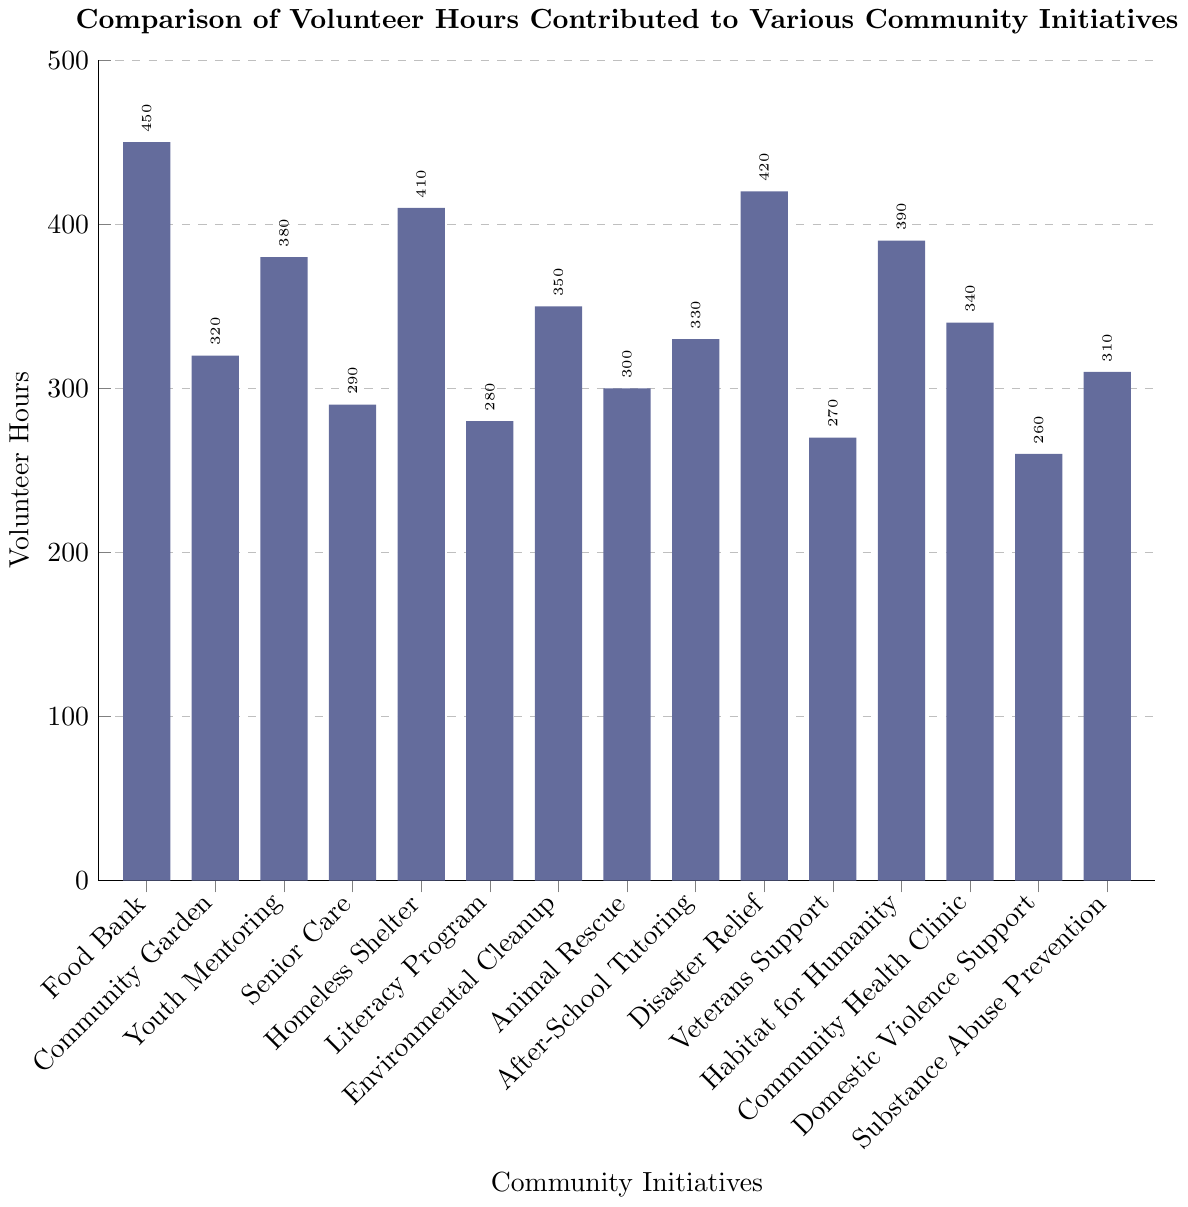What initiative received the highest number of volunteer hours? The initiative with the highest bar corresponds to the Food Bank with 450 volunteer hours.
Answer: Food Bank Which two initiatives have the closest number of volunteer hours? By visually comparing the heights of the bars, Habitate for Humanity (390 hours) and Youth Mentoring (380 hours) have the closest values.
Answer: Habitat for Humanity and Youth Mentoring What is the difference in volunteer hours between the initiative with the highest and the lowest contributions? The highest volunteer hours are for Food Bank (450 hours), and the lowest is for Domestic Violence Support (260 hours). The difference is 450 - 260 = 190 hours.
Answer: 190 hours How many initiatives have volunteer hours greater than 350 hours? Initiatives with more than 350 hours are Food Bank (450), Homeless Shelter (410), Disaster Relief (420), Habitat for Humanity (390), and Youth Mentoring (380), totaling 5 initiatives.
Answer: 5 initiatives What is the total number of volunteer hours for all initiatives combined? Summing all the volunteer hours given:
450 + 320 + 380 + 290 + 410 + 280 + 350 + 300 + 330 + 420 + 270 + 390 + 340 + 260 + 310 = 5500 hours.
Answer: 5500 hours What is the average number of volunteer hours across all initiatives? First, find the total hours, which is 5500 hours. There are 15 initiatives. So, the average is 5500 / 15 = approximately 366.67 hours.
Answer: 366.67 hours Which initiatives have volunteer hours below the average? The average is approximately 366.67 hours. Initiatives below this value include:
- Community Garden (320 hours)
- Senior Care (290 hours)
- Literacy Program (280 hours)
- Animal Rescue (300 hours)
- Veterans Support (270 hours)
- Domestic Violence Support (260 hours)
- Substance Abuse Prevention (310 hours)
Answer: Community Garden, Senior Care, Literacy Program, Animal Rescue, Veterans Support, Domestic Violence Support, Substance Abuse Prevention What is the combined volunteer hours for Environment Cleanup, Animal Rescue, and Community Health Clinic? Their hours are 350 + 300 + 340. Adding these gives 350 + 300 = 650, then 650 + 340 = 990.
Answer: 990 hours Which initiative received 30 hours more or less than the Community Health Clinic? Community Health Clinic received 340 hours. Initiatives with 30 hours more are Disaster Relief (340 + 30 = 370) and there are no initiatives with exactly 370 hours. Initiatives with 30 hours less are Youth Mentoring (370 - 30 = 310) and Substance Abuse Prevention with 310 hours.
Answer: Substance Abuse Prevention 